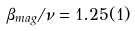<formula> <loc_0><loc_0><loc_500><loc_500>\beta _ { m a g } / \nu = 1 . 2 5 ( 1 )</formula> 